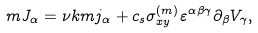<formula> <loc_0><loc_0><loc_500><loc_500>m J _ { \alpha } = \nu k m j _ { \alpha } + c _ { s } \sigma _ { x y } ^ { ( m ) } \varepsilon ^ { \alpha \beta \gamma } \partial _ { \beta } V _ { \gamma } ,</formula> 